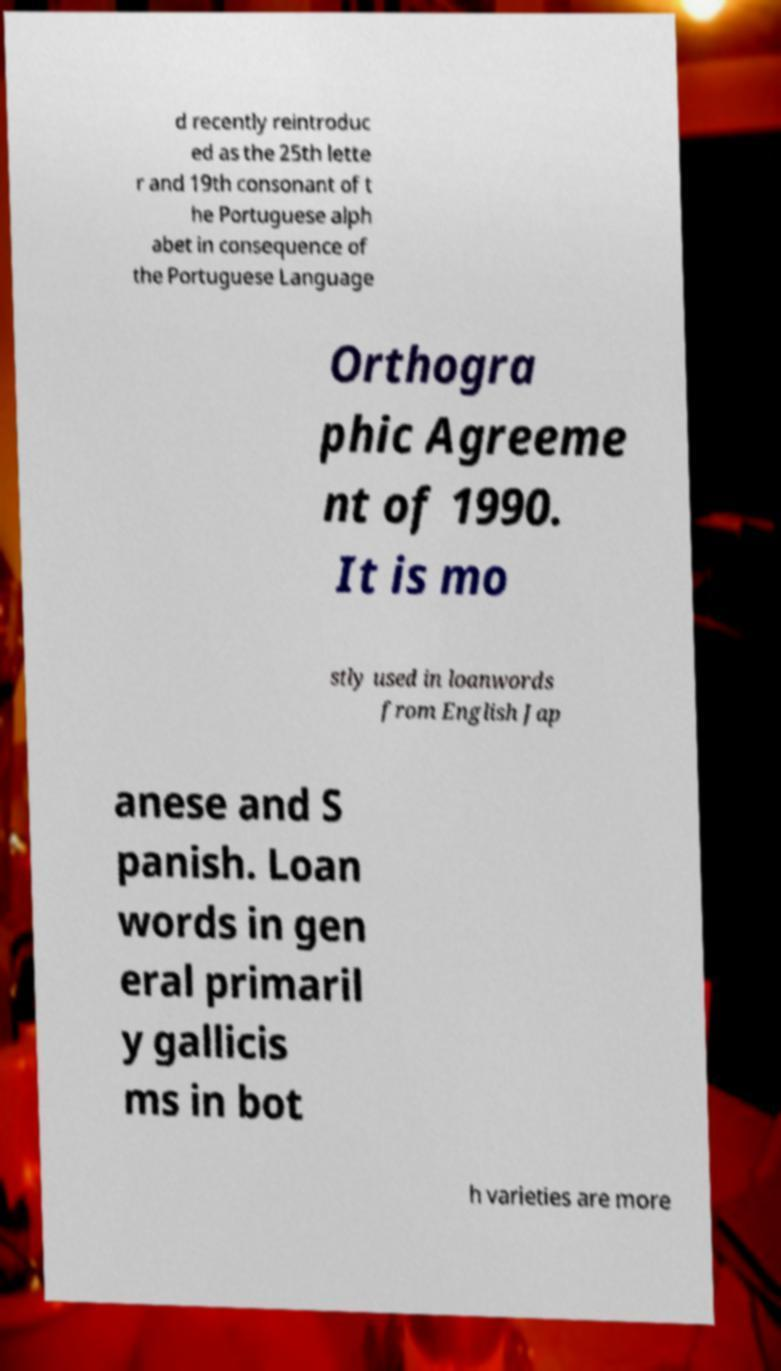Could you assist in decoding the text presented in this image and type it out clearly? d recently reintroduc ed as the 25th lette r and 19th consonant of t he Portuguese alph abet in consequence of the Portuguese Language Orthogra phic Agreeme nt of 1990. It is mo stly used in loanwords from English Jap anese and S panish. Loan words in gen eral primaril y gallicis ms in bot h varieties are more 